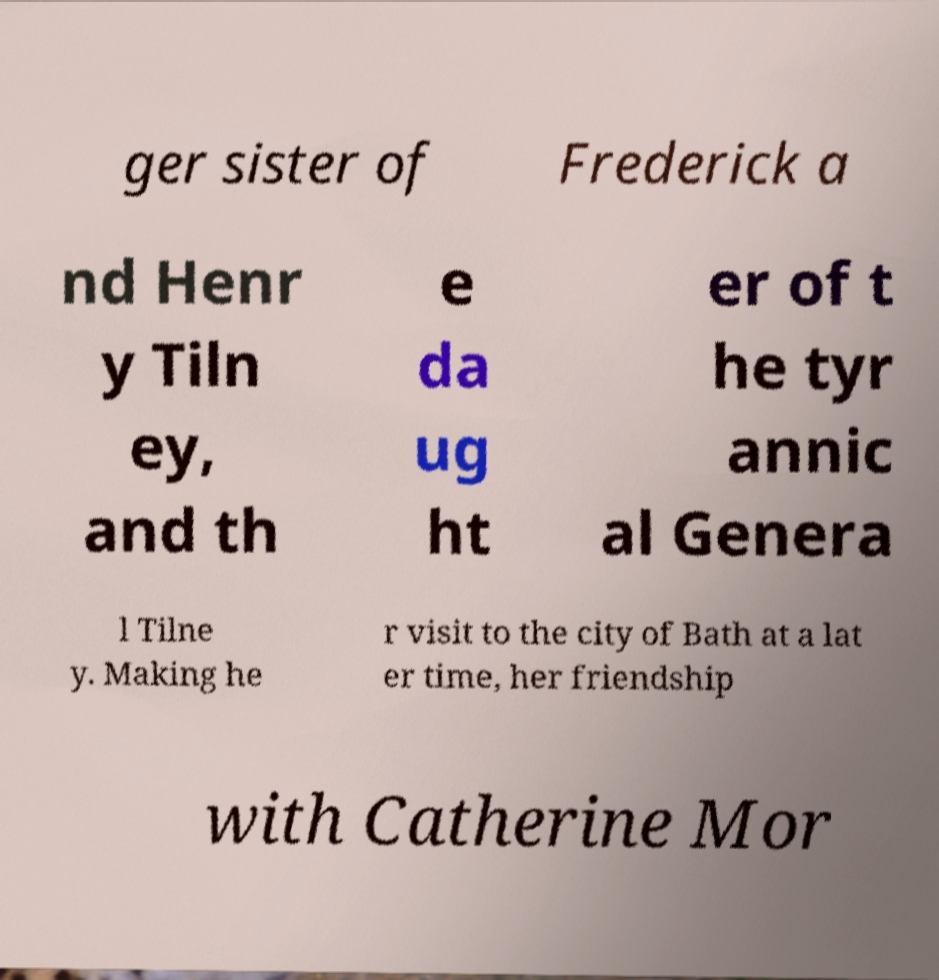I need the written content from this picture converted into text. Can you do that? ger sister of Frederick a nd Henr y Tiln ey, and th e da ug ht er of t he tyr annic al Genera l Tilne y. Making he r visit to the city of Bath at a lat er time, her friendship with Catherine Mor 